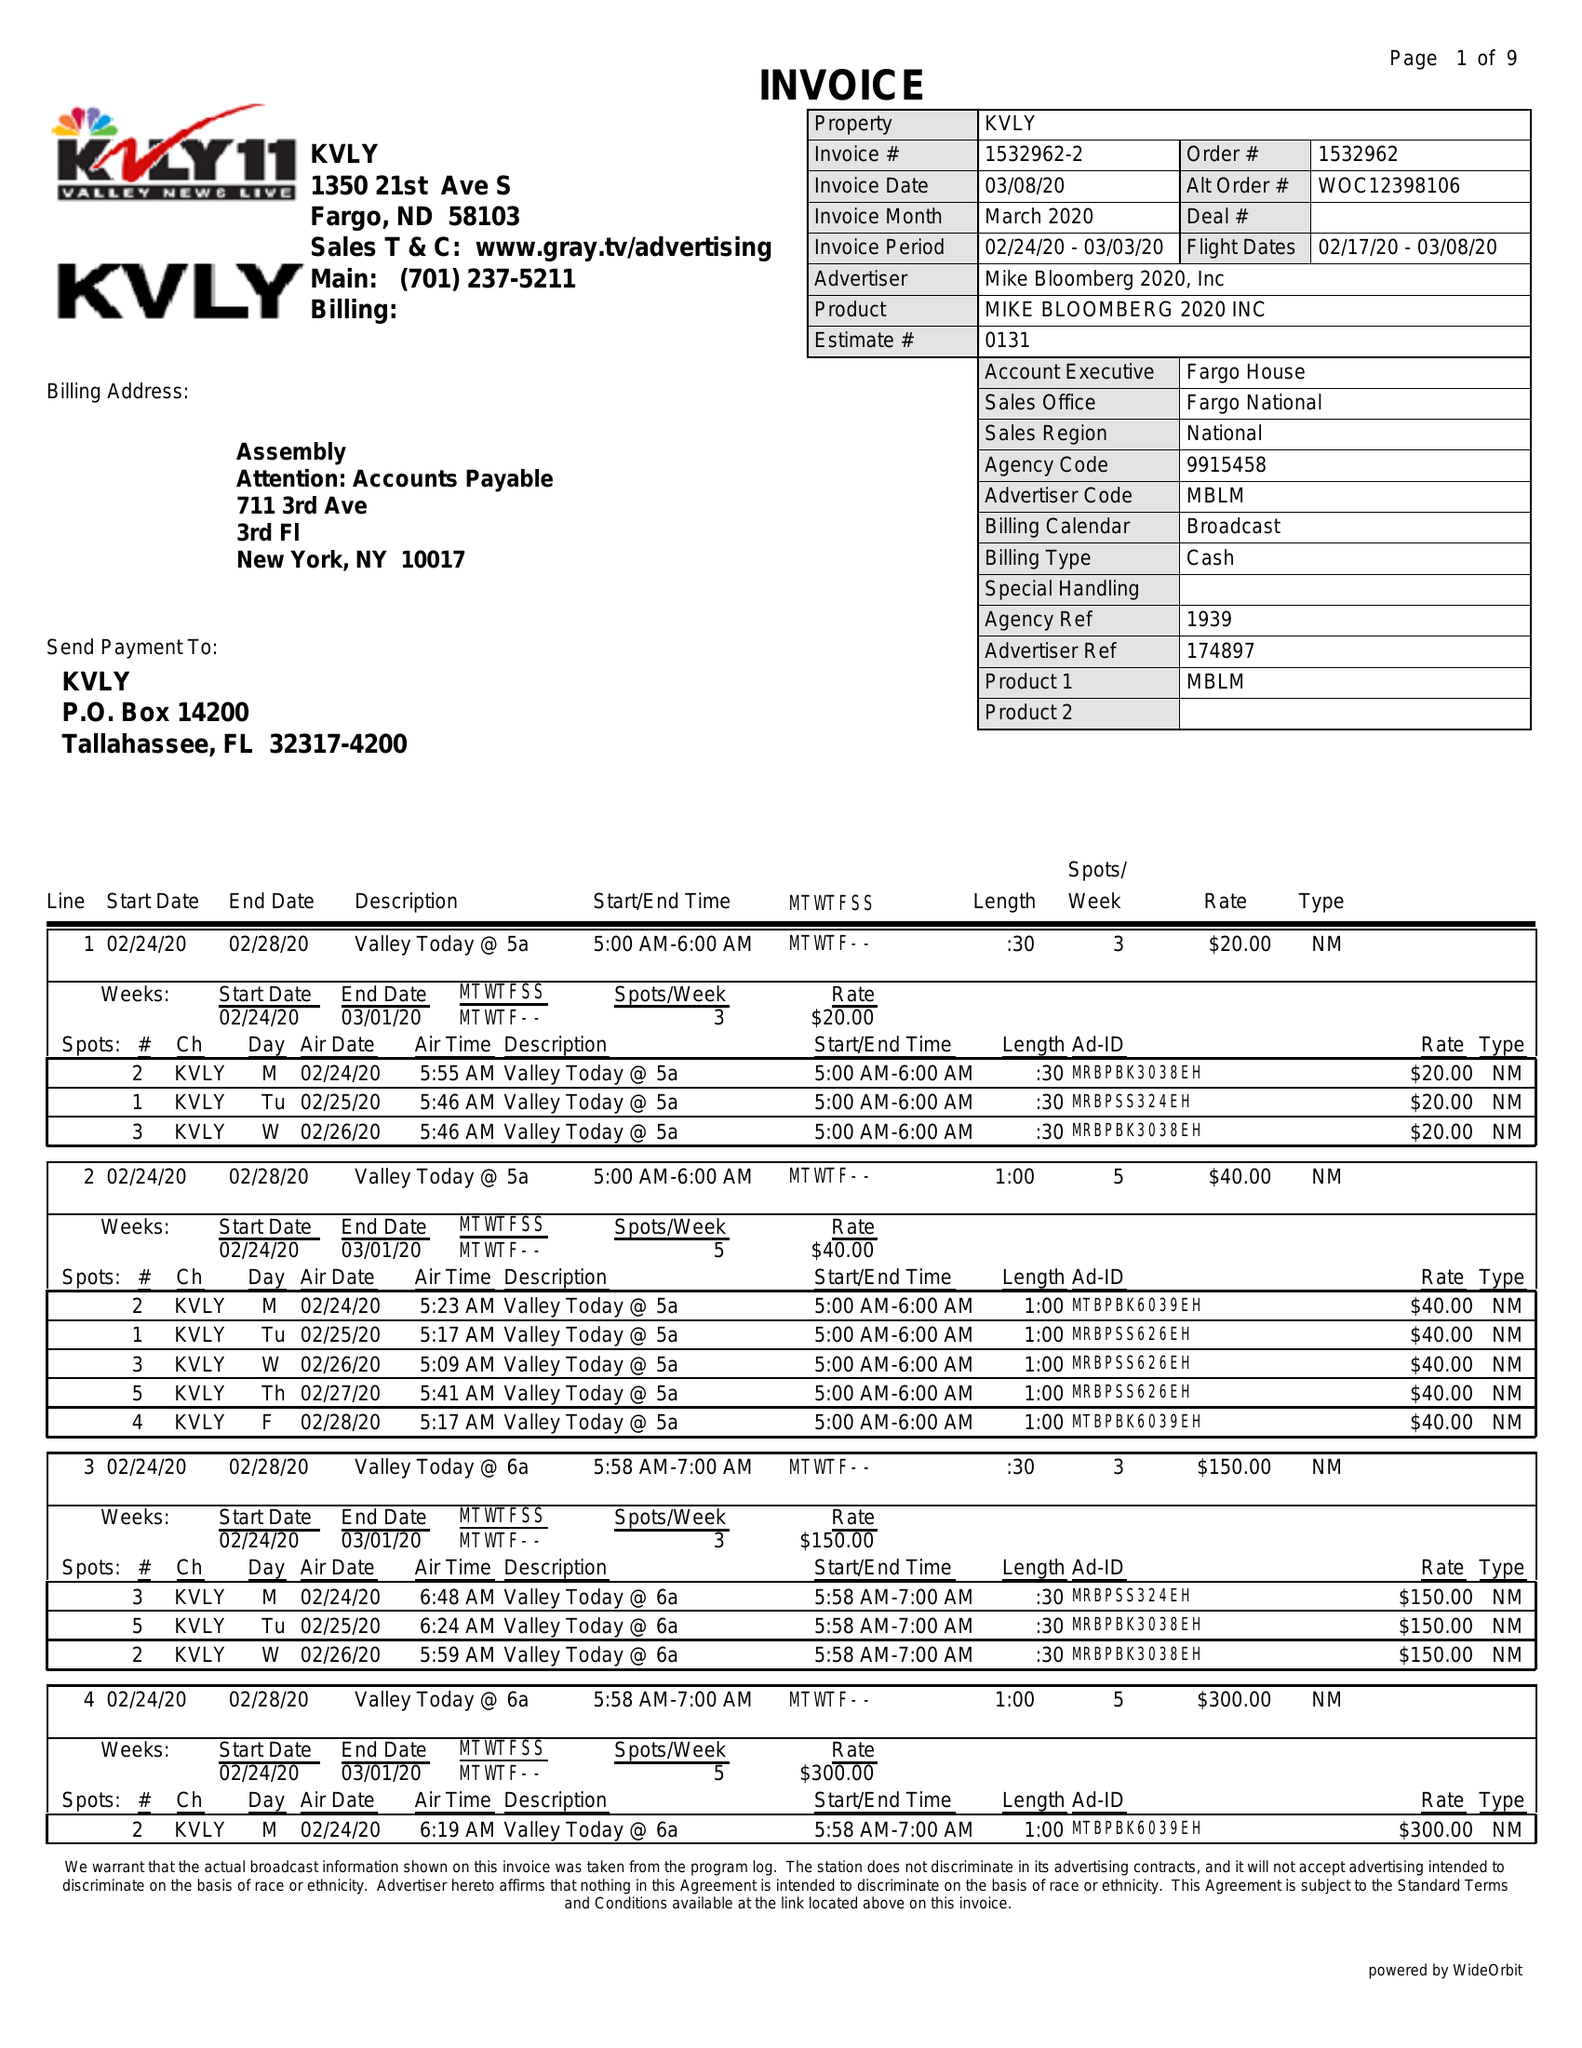What is the value for the flight_to?
Answer the question using a single word or phrase. 03/08/20 